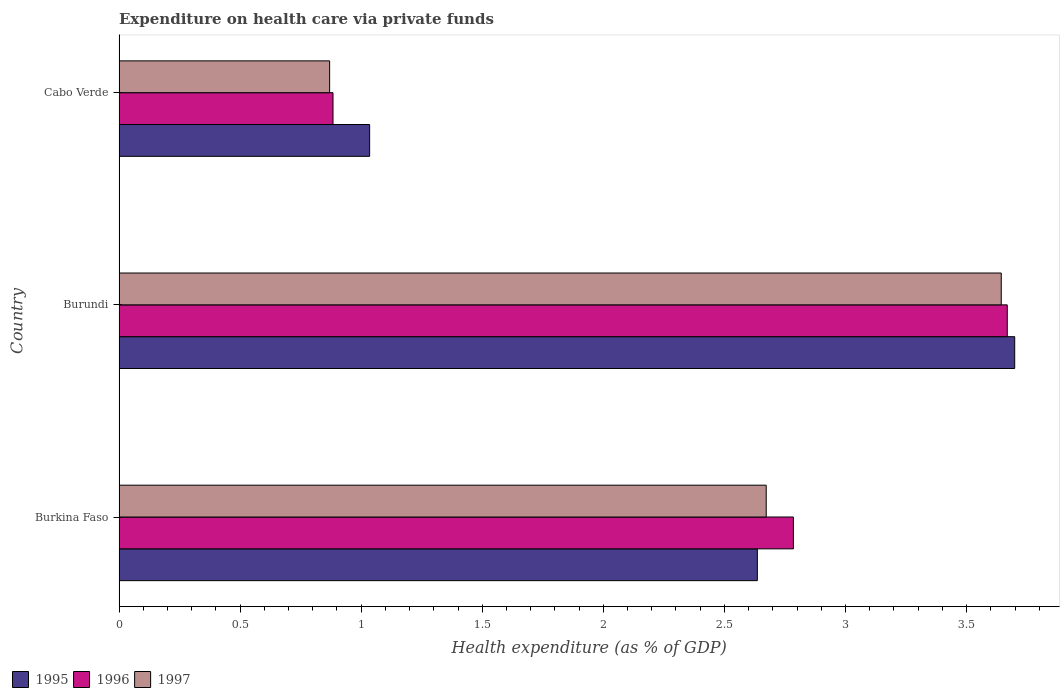How many different coloured bars are there?
Provide a short and direct response. 3. How many groups of bars are there?
Your answer should be compact. 3. Are the number of bars on each tick of the Y-axis equal?
Make the answer very short. Yes. What is the label of the 3rd group of bars from the top?
Keep it short and to the point. Burkina Faso. What is the expenditure made on health care in 1995 in Burundi?
Your answer should be very brief. 3.7. Across all countries, what is the maximum expenditure made on health care in 1997?
Your answer should be very brief. 3.64. Across all countries, what is the minimum expenditure made on health care in 1996?
Provide a short and direct response. 0.88. In which country was the expenditure made on health care in 1997 maximum?
Offer a terse response. Burundi. In which country was the expenditure made on health care in 1997 minimum?
Give a very brief answer. Cabo Verde. What is the total expenditure made on health care in 1996 in the graph?
Offer a terse response. 7.34. What is the difference between the expenditure made on health care in 1995 in Burkina Faso and that in Burundi?
Provide a short and direct response. -1.06. What is the difference between the expenditure made on health care in 1995 in Burkina Faso and the expenditure made on health care in 1997 in Cabo Verde?
Give a very brief answer. 1.77. What is the average expenditure made on health care in 1996 per country?
Ensure brevity in your answer.  2.45. What is the difference between the expenditure made on health care in 1996 and expenditure made on health care in 1995 in Cabo Verde?
Your response must be concise. -0.15. In how many countries, is the expenditure made on health care in 1995 greater than 0.2 %?
Make the answer very short. 3. What is the ratio of the expenditure made on health care in 1997 in Burkina Faso to that in Burundi?
Keep it short and to the point. 0.73. What is the difference between the highest and the second highest expenditure made on health care in 1996?
Your answer should be compact. 0.88. What is the difference between the highest and the lowest expenditure made on health care in 1995?
Give a very brief answer. 2.66. In how many countries, is the expenditure made on health care in 1995 greater than the average expenditure made on health care in 1995 taken over all countries?
Provide a succinct answer. 2. Is the sum of the expenditure made on health care in 1997 in Burundi and Cabo Verde greater than the maximum expenditure made on health care in 1995 across all countries?
Your response must be concise. Yes. What does the 2nd bar from the top in Burundi represents?
Offer a very short reply. 1996. What does the 2nd bar from the bottom in Burkina Faso represents?
Provide a succinct answer. 1996. Is it the case that in every country, the sum of the expenditure made on health care in 1997 and expenditure made on health care in 1996 is greater than the expenditure made on health care in 1995?
Provide a succinct answer. Yes. How many bars are there?
Offer a very short reply. 9. How many countries are there in the graph?
Keep it short and to the point. 3. What is the difference between two consecutive major ticks on the X-axis?
Ensure brevity in your answer.  0.5. Are the values on the major ticks of X-axis written in scientific E-notation?
Offer a very short reply. No. Does the graph contain grids?
Your answer should be very brief. No. What is the title of the graph?
Keep it short and to the point. Expenditure on health care via private funds. What is the label or title of the X-axis?
Offer a very short reply. Health expenditure (as % of GDP). What is the label or title of the Y-axis?
Your answer should be very brief. Country. What is the Health expenditure (as % of GDP) in 1995 in Burkina Faso?
Keep it short and to the point. 2.64. What is the Health expenditure (as % of GDP) in 1996 in Burkina Faso?
Give a very brief answer. 2.78. What is the Health expenditure (as % of GDP) in 1997 in Burkina Faso?
Offer a terse response. 2.67. What is the Health expenditure (as % of GDP) of 1995 in Burundi?
Offer a terse response. 3.7. What is the Health expenditure (as % of GDP) in 1996 in Burundi?
Provide a succinct answer. 3.67. What is the Health expenditure (as % of GDP) in 1997 in Burundi?
Offer a very short reply. 3.64. What is the Health expenditure (as % of GDP) in 1995 in Cabo Verde?
Provide a succinct answer. 1.03. What is the Health expenditure (as % of GDP) in 1996 in Cabo Verde?
Your answer should be compact. 0.88. What is the Health expenditure (as % of GDP) in 1997 in Cabo Verde?
Offer a very short reply. 0.87. Across all countries, what is the maximum Health expenditure (as % of GDP) of 1995?
Your response must be concise. 3.7. Across all countries, what is the maximum Health expenditure (as % of GDP) of 1996?
Keep it short and to the point. 3.67. Across all countries, what is the maximum Health expenditure (as % of GDP) of 1997?
Offer a terse response. 3.64. Across all countries, what is the minimum Health expenditure (as % of GDP) of 1995?
Offer a very short reply. 1.03. Across all countries, what is the minimum Health expenditure (as % of GDP) of 1996?
Give a very brief answer. 0.88. Across all countries, what is the minimum Health expenditure (as % of GDP) of 1997?
Keep it short and to the point. 0.87. What is the total Health expenditure (as % of GDP) of 1995 in the graph?
Your answer should be compact. 7.37. What is the total Health expenditure (as % of GDP) in 1996 in the graph?
Your response must be concise. 7.34. What is the total Health expenditure (as % of GDP) in 1997 in the graph?
Offer a terse response. 7.19. What is the difference between the Health expenditure (as % of GDP) in 1995 in Burkina Faso and that in Burundi?
Your answer should be very brief. -1.06. What is the difference between the Health expenditure (as % of GDP) in 1996 in Burkina Faso and that in Burundi?
Give a very brief answer. -0.88. What is the difference between the Health expenditure (as % of GDP) in 1997 in Burkina Faso and that in Burundi?
Ensure brevity in your answer.  -0.97. What is the difference between the Health expenditure (as % of GDP) of 1995 in Burkina Faso and that in Cabo Verde?
Provide a short and direct response. 1.6. What is the difference between the Health expenditure (as % of GDP) of 1996 in Burkina Faso and that in Cabo Verde?
Your response must be concise. 1.9. What is the difference between the Health expenditure (as % of GDP) of 1997 in Burkina Faso and that in Cabo Verde?
Provide a short and direct response. 1.8. What is the difference between the Health expenditure (as % of GDP) in 1995 in Burundi and that in Cabo Verde?
Your answer should be compact. 2.66. What is the difference between the Health expenditure (as % of GDP) of 1996 in Burundi and that in Cabo Verde?
Ensure brevity in your answer.  2.78. What is the difference between the Health expenditure (as % of GDP) of 1997 in Burundi and that in Cabo Verde?
Provide a succinct answer. 2.77. What is the difference between the Health expenditure (as % of GDP) in 1995 in Burkina Faso and the Health expenditure (as % of GDP) in 1996 in Burundi?
Provide a succinct answer. -1.03. What is the difference between the Health expenditure (as % of GDP) in 1995 in Burkina Faso and the Health expenditure (as % of GDP) in 1997 in Burundi?
Make the answer very short. -1.01. What is the difference between the Health expenditure (as % of GDP) in 1996 in Burkina Faso and the Health expenditure (as % of GDP) in 1997 in Burundi?
Make the answer very short. -0.86. What is the difference between the Health expenditure (as % of GDP) of 1995 in Burkina Faso and the Health expenditure (as % of GDP) of 1996 in Cabo Verde?
Ensure brevity in your answer.  1.75. What is the difference between the Health expenditure (as % of GDP) in 1995 in Burkina Faso and the Health expenditure (as % of GDP) in 1997 in Cabo Verde?
Your answer should be very brief. 1.77. What is the difference between the Health expenditure (as % of GDP) of 1996 in Burkina Faso and the Health expenditure (as % of GDP) of 1997 in Cabo Verde?
Provide a succinct answer. 1.92. What is the difference between the Health expenditure (as % of GDP) in 1995 in Burundi and the Health expenditure (as % of GDP) in 1996 in Cabo Verde?
Offer a terse response. 2.82. What is the difference between the Health expenditure (as % of GDP) of 1995 in Burundi and the Health expenditure (as % of GDP) of 1997 in Cabo Verde?
Your response must be concise. 2.83. What is the difference between the Health expenditure (as % of GDP) in 1996 in Burundi and the Health expenditure (as % of GDP) in 1997 in Cabo Verde?
Ensure brevity in your answer.  2.8. What is the average Health expenditure (as % of GDP) in 1995 per country?
Keep it short and to the point. 2.46. What is the average Health expenditure (as % of GDP) of 1996 per country?
Provide a short and direct response. 2.45. What is the average Health expenditure (as % of GDP) of 1997 per country?
Provide a short and direct response. 2.4. What is the difference between the Health expenditure (as % of GDP) of 1995 and Health expenditure (as % of GDP) of 1996 in Burkina Faso?
Provide a short and direct response. -0.15. What is the difference between the Health expenditure (as % of GDP) of 1995 and Health expenditure (as % of GDP) of 1997 in Burkina Faso?
Provide a short and direct response. -0.04. What is the difference between the Health expenditure (as % of GDP) in 1996 and Health expenditure (as % of GDP) in 1997 in Burkina Faso?
Provide a succinct answer. 0.11. What is the difference between the Health expenditure (as % of GDP) of 1995 and Health expenditure (as % of GDP) of 1996 in Burundi?
Your answer should be compact. 0.03. What is the difference between the Health expenditure (as % of GDP) in 1995 and Health expenditure (as % of GDP) in 1997 in Burundi?
Keep it short and to the point. 0.06. What is the difference between the Health expenditure (as % of GDP) of 1996 and Health expenditure (as % of GDP) of 1997 in Burundi?
Provide a succinct answer. 0.02. What is the difference between the Health expenditure (as % of GDP) of 1995 and Health expenditure (as % of GDP) of 1996 in Cabo Verde?
Your answer should be compact. 0.15. What is the difference between the Health expenditure (as % of GDP) in 1995 and Health expenditure (as % of GDP) in 1997 in Cabo Verde?
Your answer should be compact. 0.17. What is the difference between the Health expenditure (as % of GDP) of 1996 and Health expenditure (as % of GDP) of 1997 in Cabo Verde?
Offer a very short reply. 0.01. What is the ratio of the Health expenditure (as % of GDP) of 1995 in Burkina Faso to that in Burundi?
Ensure brevity in your answer.  0.71. What is the ratio of the Health expenditure (as % of GDP) in 1996 in Burkina Faso to that in Burundi?
Give a very brief answer. 0.76. What is the ratio of the Health expenditure (as % of GDP) in 1997 in Burkina Faso to that in Burundi?
Provide a succinct answer. 0.73. What is the ratio of the Health expenditure (as % of GDP) of 1995 in Burkina Faso to that in Cabo Verde?
Offer a terse response. 2.55. What is the ratio of the Health expenditure (as % of GDP) in 1996 in Burkina Faso to that in Cabo Verde?
Make the answer very short. 3.15. What is the ratio of the Health expenditure (as % of GDP) of 1997 in Burkina Faso to that in Cabo Verde?
Your response must be concise. 3.07. What is the ratio of the Health expenditure (as % of GDP) of 1995 in Burundi to that in Cabo Verde?
Make the answer very short. 3.57. What is the ratio of the Health expenditure (as % of GDP) in 1996 in Burundi to that in Cabo Verde?
Offer a very short reply. 4.15. What is the ratio of the Health expenditure (as % of GDP) in 1997 in Burundi to that in Cabo Verde?
Your answer should be very brief. 4.19. What is the difference between the highest and the second highest Health expenditure (as % of GDP) in 1995?
Your answer should be compact. 1.06. What is the difference between the highest and the second highest Health expenditure (as % of GDP) in 1996?
Your answer should be very brief. 0.88. What is the difference between the highest and the second highest Health expenditure (as % of GDP) of 1997?
Your response must be concise. 0.97. What is the difference between the highest and the lowest Health expenditure (as % of GDP) of 1995?
Your response must be concise. 2.66. What is the difference between the highest and the lowest Health expenditure (as % of GDP) of 1996?
Your response must be concise. 2.78. What is the difference between the highest and the lowest Health expenditure (as % of GDP) in 1997?
Your answer should be very brief. 2.77. 